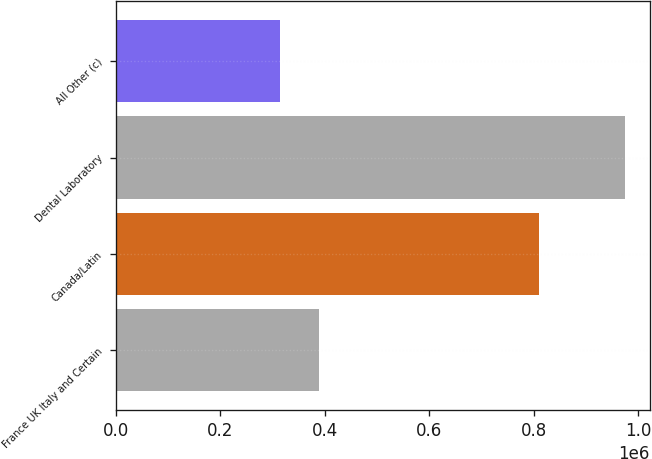<chart> <loc_0><loc_0><loc_500><loc_500><bar_chart><fcel>France UK Italy and Certain<fcel>Canada/Latin<fcel>Dental Laboratory<fcel>All Other (c)<nl><fcel>388831<fcel>809924<fcel>973764<fcel>313141<nl></chart> 